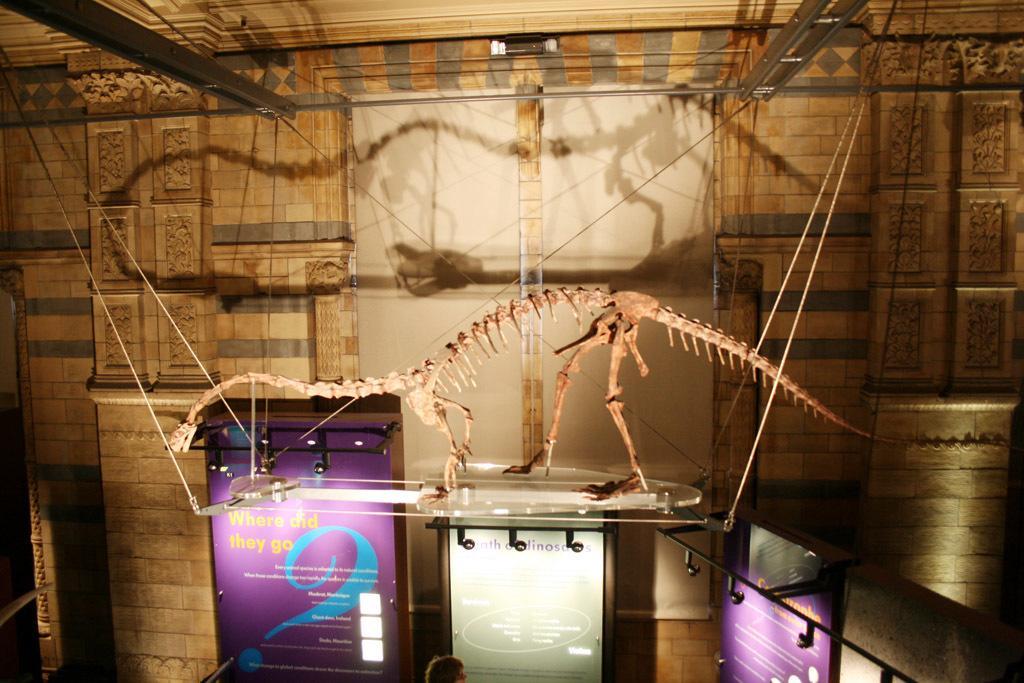Can you describe this image briefly? In the image there is a glass stand hanging with ropes. On that stand there is a skeleton of an animal. Below the stand there are banners with some text on it. And in the background there is a wall with designer pillars. 